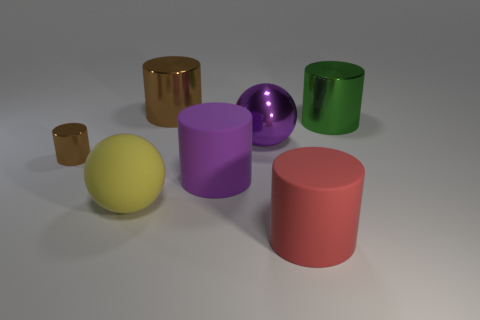Subtract all matte cylinders. How many cylinders are left? 3 Subtract all red cylinders. How many cylinders are left? 4 Add 1 big yellow rubber balls. How many objects exist? 8 Add 1 yellow matte objects. How many yellow matte objects are left? 2 Add 5 cylinders. How many cylinders exist? 10 Subtract 0 gray cylinders. How many objects are left? 7 Subtract all balls. How many objects are left? 5 Subtract 1 cylinders. How many cylinders are left? 4 Subtract all yellow balls. Subtract all yellow cubes. How many balls are left? 1 Subtract all brown balls. How many brown cylinders are left? 2 